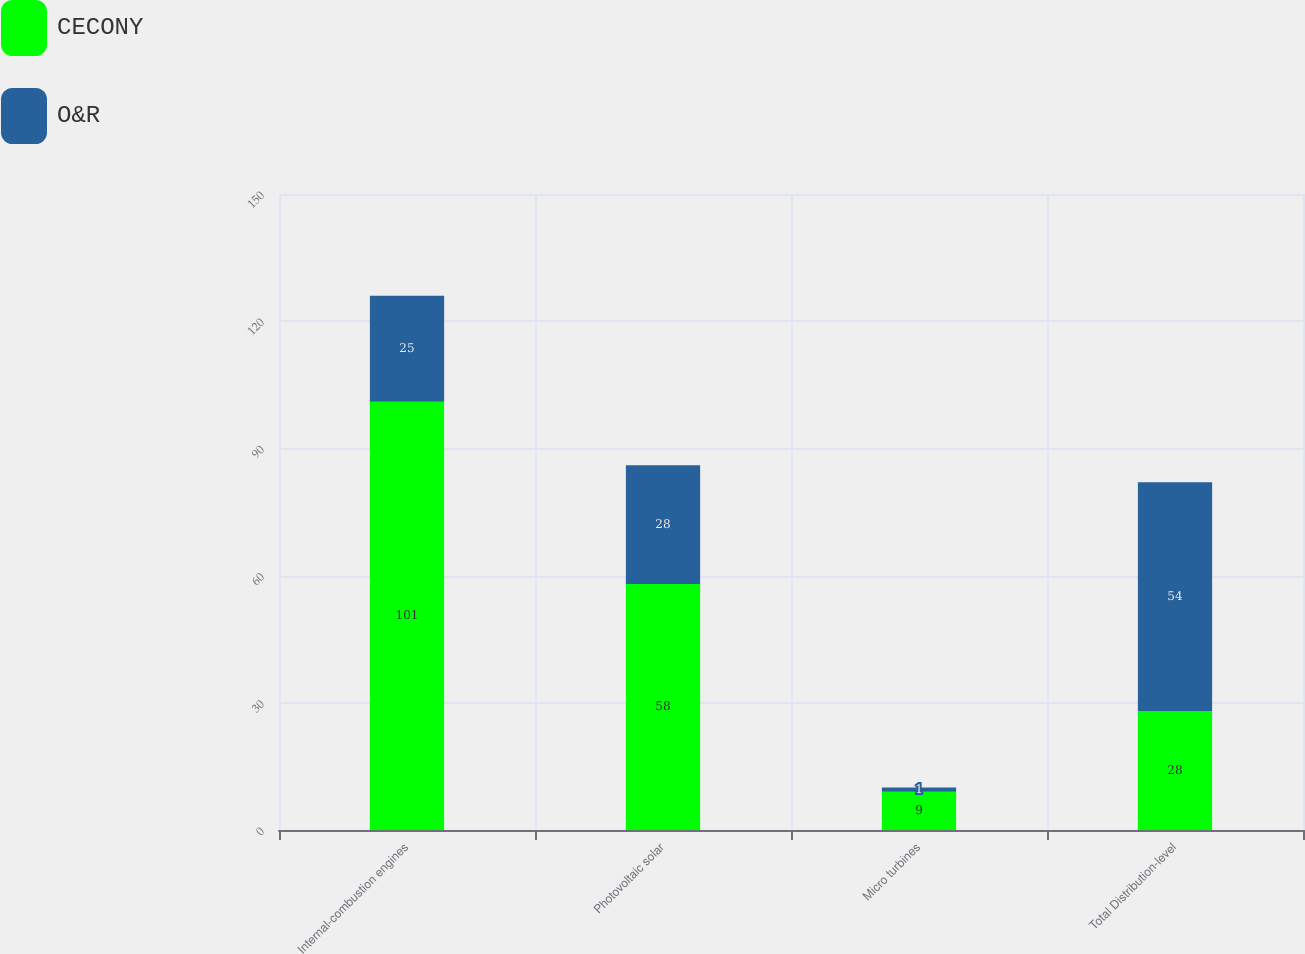Convert chart to OTSL. <chart><loc_0><loc_0><loc_500><loc_500><stacked_bar_chart><ecel><fcel>Internal-combustion engines<fcel>Photovoltaic solar<fcel>Micro turbines<fcel>Total Distribution-level<nl><fcel>CECONY<fcel>101<fcel>58<fcel>9<fcel>28<nl><fcel>O&R<fcel>25<fcel>28<fcel>1<fcel>54<nl></chart> 